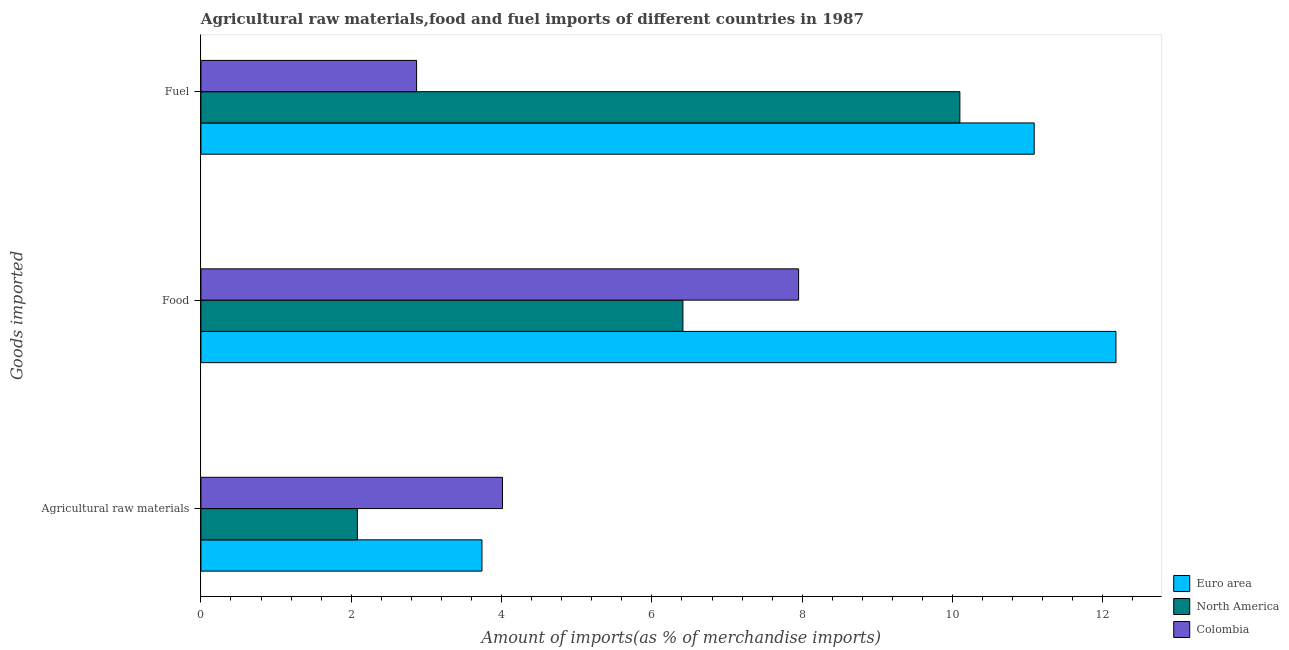How many groups of bars are there?
Offer a terse response. 3. Are the number of bars on each tick of the Y-axis equal?
Give a very brief answer. Yes. What is the label of the 3rd group of bars from the top?
Keep it short and to the point. Agricultural raw materials. What is the percentage of food imports in Euro area?
Your answer should be compact. 12.17. Across all countries, what is the maximum percentage of raw materials imports?
Your answer should be compact. 4.01. Across all countries, what is the minimum percentage of fuel imports?
Your answer should be very brief. 2.87. In which country was the percentage of food imports maximum?
Keep it short and to the point. Euro area. What is the total percentage of raw materials imports in the graph?
Offer a very short reply. 9.83. What is the difference between the percentage of raw materials imports in North America and that in Colombia?
Your answer should be compact. -1.93. What is the difference between the percentage of raw materials imports in Colombia and the percentage of fuel imports in North America?
Your answer should be very brief. -6.08. What is the average percentage of fuel imports per country?
Your answer should be compact. 8.02. What is the difference between the percentage of raw materials imports and percentage of food imports in Euro area?
Provide a succinct answer. -8.43. In how many countries, is the percentage of food imports greater than 10.8 %?
Your answer should be very brief. 1. What is the ratio of the percentage of fuel imports in North America to that in Euro area?
Ensure brevity in your answer.  0.91. What is the difference between the highest and the second highest percentage of raw materials imports?
Provide a short and direct response. 0.27. What is the difference between the highest and the lowest percentage of fuel imports?
Keep it short and to the point. 8.22. In how many countries, is the percentage of fuel imports greater than the average percentage of fuel imports taken over all countries?
Keep it short and to the point. 2. Is the sum of the percentage of raw materials imports in Euro area and North America greater than the maximum percentage of food imports across all countries?
Make the answer very short. No. What does the 2nd bar from the top in Food represents?
Your response must be concise. North America. What does the 3rd bar from the bottom in Fuel represents?
Ensure brevity in your answer.  Colombia. Is it the case that in every country, the sum of the percentage of raw materials imports and percentage of food imports is greater than the percentage of fuel imports?
Give a very brief answer. No. Are all the bars in the graph horizontal?
Your response must be concise. Yes. How many countries are there in the graph?
Offer a very short reply. 3. What is the difference between two consecutive major ticks on the X-axis?
Your response must be concise. 2. Are the values on the major ticks of X-axis written in scientific E-notation?
Offer a very short reply. No. Does the graph contain any zero values?
Provide a short and direct response. No. Does the graph contain grids?
Your answer should be compact. No. Where does the legend appear in the graph?
Provide a short and direct response. Bottom right. What is the title of the graph?
Ensure brevity in your answer.  Agricultural raw materials,food and fuel imports of different countries in 1987. Does "Marshall Islands" appear as one of the legend labels in the graph?
Provide a short and direct response. No. What is the label or title of the X-axis?
Provide a succinct answer. Amount of imports(as % of merchandise imports). What is the label or title of the Y-axis?
Keep it short and to the point. Goods imported. What is the Amount of imports(as % of merchandise imports) in Euro area in Agricultural raw materials?
Keep it short and to the point. 3.74. What is the Amount of imports(as % of merchandise imports) in North America in Agricultural raw materials?
Provide a short and direct response. 2.08. What is the Amount of imports(as % of merchandise imports) of Colombia in Agricultural raw materials?
Offer a very short reply. 4.01. What is the Amount of imports(as % of merchandise imports) of Euro area in Food?
Provide a succinct answer. 12.17. What is the Amount of imports(as % of merchandise imports) of North America in Food?
Provide a short and direct response. 6.41. What is the Amount of imports(as % of merchandise imports) in Colombia in Food?
Provide a short and direct response. 7.95. What is the Amount of imports(as % of merchandise imports) in Euro area in Fuel?
Keep it short and to the point. 11.09. What is the Amount of imports(as % of merchandise imports) in North America in Fuel?
Your response must be concise. 10.1. What is the Amount of imports(as % of merchandise imports) in Colombia in Fuel?
Offer a very short reply. 2.87. Across all Goods imported, what is the maximum Amount of imports(as % of merchandise imports) in Euro area?
Offer a terse response. 12.17. Across all Goods imported, what is the maximum Amount of imports(as % of merchandise imports) of North America?
Your response must be concise. 10.1. Across all Goods imported, what is the maximum Amount of imports(as % of merchandise imports) in Colombia?
Your answer should be very brief. 7.95. Across all Goods imported, what is the minimum Amount of imports(as % of merchandise imports) in Euro area?
Your answer should be compact. 3.74. Across all Goods imported, what is the minimum Amount of imports(as % of merchandise imports) in North America?
Your response must be concise. 2.08. Across all Goods imported, what is the minimum Amount of imports(as % of merchandise imports) of Colombia?
Provide a succinct answer. 2.87. What is the total Amount of imports(as % of merchandise imports) in Euro area in the graph?
Provide a succinct answer. 27. What is the total Amount of imports(as % of merchandise imports) of North America in the graph?
Offer a very short reply. 18.59. What is the total Amount of imports(as % of merchandise imports) in Colombia in the graph?
Keep it short and to the point. 14.83. What is the difference between the Amount of imports(as % of merchandise imports) in Euro area in Agricultural raw materials and that in Food?
Provide a succinct answer. -8.43. What is the difference between the Amount of imports(as % of merchandise imports) of North America in Agricultural raw materials and that in Food?
Make the answer very short. -4.33. What is the difference between the Amount of imports(as % of merchandise imports) in Colombia in Agricultural raw materials and that in Food?
Your answer should be compact. -3.94. What is the difference between the Amount of imports(as % of merchandise imports) of Euro area in Agricultural raw materials and that in Fuel?
Ensure brevity in your answer.  -7.35. What is the difference between the Amount of imports(as % of merchandise imports) of North America in Agricultural raw materials and that in Fuel?
Provide a succinct answer. -8.02. What is the difference between the Amount of imports(as % of merchandise imports) in Colombia in Agricultural raw materials and that in Fuel?
Keep it short and to the point. 1.14. What is the difference between the Amount of imports(as % of merchandise imports) of Euro area in Food and that in Fuel?
Provide a short and direct response. 1.09. What is the difference between the Amount of imports(as % of merchandise imports) of North America in Food and that in Fuel?
Your response must be concise. -3.68. What is the difference between the Amount of imports(as % of merchandise imports) in Colombia in Food and that in Fuel?
Ensure brevity in your answer.  5.08. What is the difference between the Amount of imports(as % of merchandise imports) in Euro area in Agricultural raw materials and the Amount of imports(as % of merchandise imports) in North America in Food?
Your response must be concise. -2.67. What is the difference between the Amount of imports(as % of merchandise imports) of Euro area in Agricultural raw materials and the Amount of imports(as % of merchandise imports) of Colombia in Food?
Your answer should be very brief. -4.21. What is the difference between the Amount of imports(as % of merchandise imports) in North America in Agricultural raw materials and the Amount of imports(as % of merchandise imports) in Colombia in Food?
Offer a very short reply. -5.87. What is the difference between the Amount of imports(as % of merchandise imports) in Euro area in Agricultural raw materials and the Amount of imports(as % of merchandise imports) in North America in Fuel?
Give a very brief answer. -6.36. What is the difference between the Amount of imports(as % of merchandise imports) of Euro area in Agricultural raw materials and the Amount of imports(as % of merchandise imports) of Colombia in Fuel?
Keep it short and to the point. 0.87. What is the difference between the Amount of imports(as % of merchandise imports) of North America in Agricultural raw materials and the Amount of imports(as % of merchandise imports) of Colombia in Fuel?
Ensure brevity in your answer.  -0.79. What is the difference between the Amount of imports(as % of merchandise imports) of Euro area in Food and the Amount of imports(as % of merchandise imports) of North America in Fuel?
Offer a very short reply. 2.08. What is the difference between the Amount of imports(as % of merchandise imports) of Euro area in Food and the Amount of imports(as % of merchandise imports) of Colombia in Fuel?
Keep it short and to the point. 9.3. What is the difference between the Amount of imports(as % of merchandise imports) of North America in Food and the Amount of imports(as % of merchandise imports) of Colombia in Fuel?
Provide a short and direct response. 3.54. What is the average Amount of imports(as % of merchandise imports) in Euro area per Goods imported?
Provide a succinct answer. 9. What is the average Amount of imports(as % of merchandise imports) of North America per Goods imported?
Provide a short and direct response. 6.2. What is the average Amount of imports(as % of merchandise imports) in Colombia per Goods imported?
Your response must be concise. 4.94. What is the difference between the Amount of imports(as % of merchandise imports) in Euro area and Amount of imports(as % of merchandise imports) in North America in Agricultural raw materials?
Your answer should be compact. 1.66. What is the difference between the Amount of imports(as % of merchandise imports) of Euro area and Amount of imports(as % of merchandise imports) of Colombia in Agricultural raw materials?
Your answer should be compact. -0.27. What is the difference between the Amount of imports(as % of merchandise imports) in North America and Amount of imports(as % of merchandise imports) in Colombia in Agricultural raw materials?
Offer a terse response. -1.93. What is the difference between the Amount of imports(as % of merchandise imports) in Euro area and Amount of imports(as % of merchandise imports) in North America in Food?
Provide a succinct answer. 5.76. What is the difference between the Amount of imports(as % of merchandise imports) in Euro area and Amount of imports(as % of merchandise imports) in Colombia in Food?
Offer a very short reply. 4.22. What is the difference between the Amount of imports(as % of merchandise imports) of North America and Amount of imports(as % of merchandise imports) of Colombia in Food?
Ensure brevity in your answer.  -1.54. What is the difference between the Amount of imports(as % of merchandise imports) of Euro area and Amount of imports(as % of merchandise imports) of Colombia in Fuel?
Provide a succinct answer. 8.22. What is the difference between the Amount of imports(as % of merchandise imports) in North America and Amount of imports(as % of merchandise imports) in Colombia in Fuel?
Offer a terse response. 7.23. What is the ratio of the Amount of imports(as % of merchandise imports) of Euro area in Agricultural raw materials to that in Food?
Give a very brief answer. 0.31. What is the ratio of the Amount of imports(as % of merchandise imports) of North America in Agricultural raw materials to that in Food?
Offer a terse response. 0.32. What is the ratio of the Amount of imports(as % of merchandise imports) of Colombia in Agricultural raw materials to that in Food?
Offer a terse response. 0.5. What is the ratio of the Amount of imports(as % of merchandise imports) in Euro area in Agricultural raw materials to that in Fuel?
Your response must be concise. 0.34. What is the ratio of the Amount of imports(as % of merchandise imports) of North America in Agricultural raw materials to that in Fuel?
Give a very brief answer. 0.21. What is the ratio of the Amount of imports(as % of merchandise imports) in Colombia in Agricultural raw materials to that in Fuel?
Make the answer very short. 1.4. What is the ratio of the Amount of imports(as % of merchandise imports) of Euro area in Food to that in Fuel?
Offer a terse response. 1.1. What is the ratio of the Amount of imports(as % of merchandise imports) of North America in Food to that in Fuel?
Offer a very short reply. 0.64. What is the ratio of the Amount of imports(as % of merchandise imports) in Colombia in Food to that in Fuel?
Your answer should be very brief. 2.77. What is the difference between the highest and the second highest Amount of imports(as % of merchandise imports) in Euro area?
Your response must be concise. 1.09. What is the difference between the highest and the second highest Amount of imports(as % of merchandise imports) in North America?
Make the answer very short. 3.68. What is the difference between the highest and the second highest Amount of imports(as % of merchandise imports) in Colombia?
Ensure brevity in your answer.  3.94. What is the difference between the highest and the lowest Amount of imports(as % of merchandise imports) of Euro area?
Your response must be concise. 8.43. What is the difference between the highest and the lowest Amount of imports(as % of merchandise imports) of North America?
Your answer should be very brief. 8.02. What is the difference between the highest and the lowest Amount of imports(as % of merchandise imports) of Colombia?
Your answer should be compact. 5.08. 